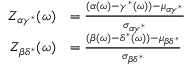<formula> <loc_0><loc_0><loc_500><loc_500>\begin{array} { r l } { Z _ { \alpha \gamma ^ { * } } ( \omega ) } & { = \frac { ( \alpha ( \omega ) - \gamma ^ { * } ( \omega ) ) - \mu _ { \alpha \gamma ^ { * } } } { \sigma _ { \alpha \gamma ^ { * } } } } \\ { Z _ { \beta \delta ^ { * } } ( \omega ) } & { = \frac { ( \beta ( \omega ) - \delta ^ { * } ( \omega ) ) - \mu _ { \beta \delta ^ { * } } } { \sigma _ { \beta \delta ^ { * } } } } \end{array}</formula> 